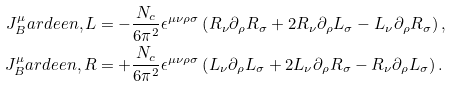<formula> <loc_0><loc_0><loc_500><loc_500>J ^ { \mu } _ { B } a r d e e n , L & = - \frac { N _ { c } } { 6 \pi ^ { 2 } } \epsilon ^ { \mu \nu \rho \sigma } \left ( R _ { \nu } \partial _ { \rho } R _ { \sigma } + 2 R _ { \nu } \partial _ { \rho } L _ { \sigma } - L _ { \nu } \partial _ { \rho } R _ { \sigma } \right ) , \\ J ^ { \mu } _ { B } a r d e e n , R & = + \frac { N _ { c } } { 6 \pi ^ { 2 } } \epsilon ^ { \mu \nu \rho \sigma } \left ( L _ { \nu } \partial _ { \rho } L _ { \sigma } + 2 L _ { \nu } \partial _ { \rho } R _ { \sigma } - R _ { \nu } \partial _ { \rho } L _ { \sigma } \right ) .</formula> 